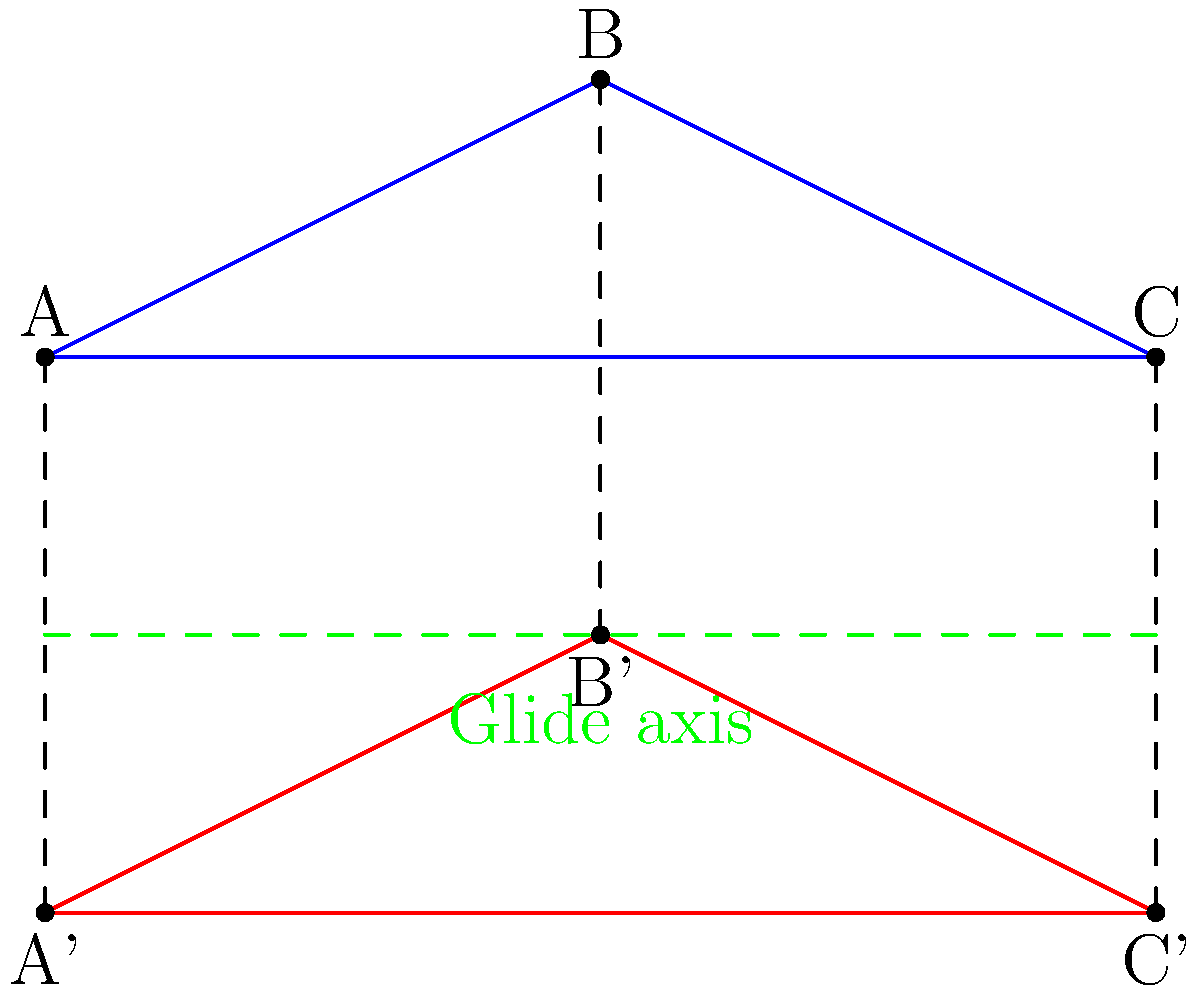In a musical film choreography, a dance sequence utilizes glide reflection to create visual symmetry. The diagram shows the initial position of three dancers (blue triangle ABC) and their final position after the glide reflection (red triangle A'B'C'). If the glide reflection involves a vertical reflection followed by a horizontal translation, what is the magnitude of the horizontal translation vector? To determine the magnitude of the horizontal translation vector in this glide reflection, we can follow these steps:

1. Identify the glide axis: The green dashed line represents the glide axis, which is the line of reflection.

2. Observe the vertical reflection: The blue triangle ABC is first reflected across the glide axis to create an intermediate position.

3. Analyze the horizontal translation: After the reflection, the triangle is translated horizontally to reach its final position (red triangle A'B'C').

4. Calculate the translation magnitude:
   a. Choose any corresponding point pair, such as A and A'.
   b. The vertical distance between A and the glide axis is the same as the distance between A' and the glide axis.
   c. The horizontal distance between A and A' represents the translation magnitude.

5. Measure the horizontal distance:
   In the given coordinate system, point A is at (0,0) and A' is at (0,-2).
   The horizontal distance between these points is 0.

Therefore, the magnitude of the horizontal translation vector is 0 units.
Answer: 0 units 